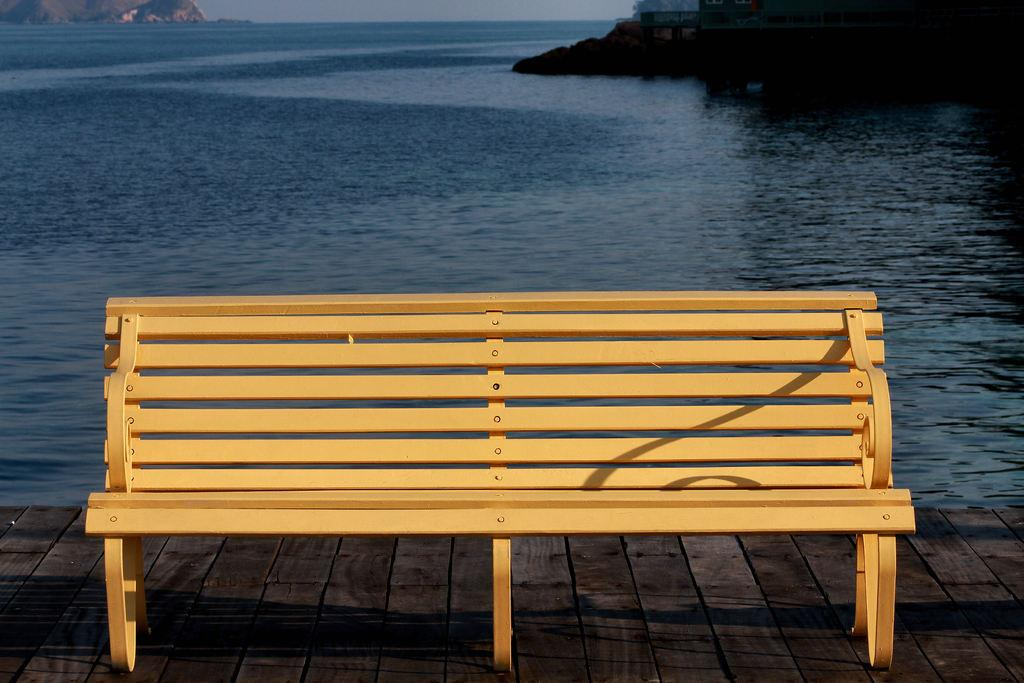What type of furniture is in the image? There is a bench in the image. What is the surface beneath the bench? The bench is on a wooden floor. What can be seen in the background of the image? There is water, mountains, and the sky visible in the background of the image. What type of cannon is present on the bench in the image? There is no cannon present on the bench or in the image. What type of lamp is used for learning purposes in the image? There is no lamp or learning activity depicted in the image. 